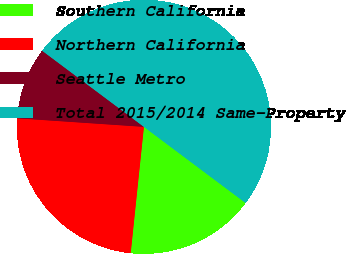<chart> <loc_0><loc_0><loc_500><loc_500><pie_chart><fcel>Southern California<fcel>Northern California<fcel>Seattle Metro<fcel>Total 2015/2014 Same-Property<nl><fcel>16.43%<fcel>24.41%<fcel>9.15%<fcel>50.0%<nl></chart> 